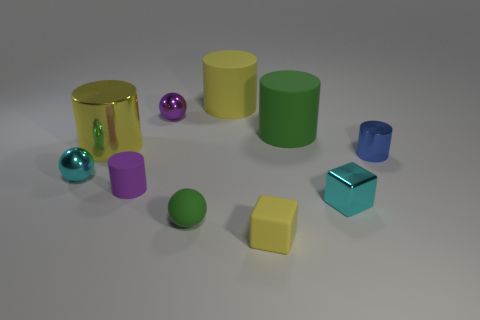Is there any other thing that is the same color as the small metal cylinder?
Make the answer very short. No. Is the shape of the tiny green thing the same as the large shiny object?
Keep it short and to the point. No. There is a matte thing that is behind the green thing that is to the right of the large yellow thing behind the big yellow metallic thing; what is its size?
Your response must be concise. Large. How many other objects are there of the same material as the purple cylinder?
Your answer should be very brief. 4. The cylinder that is to the right of the tiny cyan cube is what color?
Your answer should be compact. Blue. What material is the green thing in front of the metallic sphere in front of the metal cylinder that is to the left of the blue metal cylinder?
Provide a succinct answer. Rubber. Is there another thing that has the same shape as the yellow shiny object?
Your answer should be compact. Yes. There is a purple metallic object that is the same size as the cyan metallic block; what is its shape?
Your answer should be compact. Sphere. What number of things are in front of the purple rubber cylinder and to the left of the large green matte object?
Offer a very short reply. 2. Is the number of yellow metal cylinders that are to the left of the tiny green matte ball less than the number of tiny cyan cubes?
Provide a succinct answer. No. 